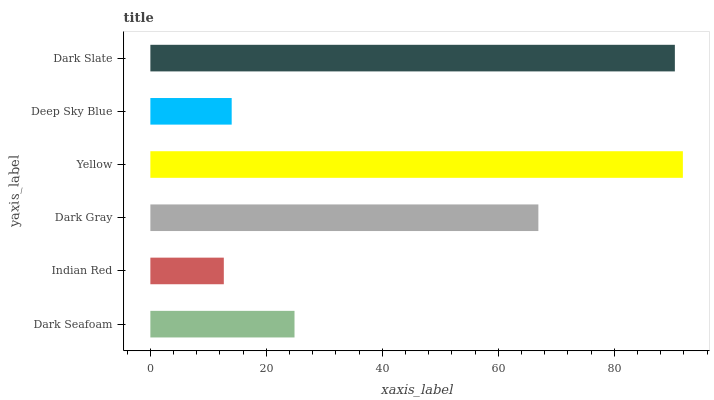Is Indian Red the minimum?
Answer yes or no. Yes. Is Yellow the maximum?
Answer yes or no. Yes. Is Dark Gray the minimum?
Answer yes or no. No. Is Dark Gray the maximum?
Answer yes or no. No. Is Dark Gray greater than Indian Red?
Answer yes or no. Yes. Is Indian Red less than Dark Gray?
Answer yes or no. Yes. Is Indian Red greater than Dark Gray?
Answer yes or no. No. Is Dark Gray less than Indian Red?
Answer yes or no. No. Is Dark Gray the high median?
Answer yes or no. Yes. Is Dark Seafoam the low median?
Answer yes or no. Yes. Is Indian Red the high median?
Answer yes or no. No. Is Deep Sky Blue the low median?
Answer yes or no. No. 